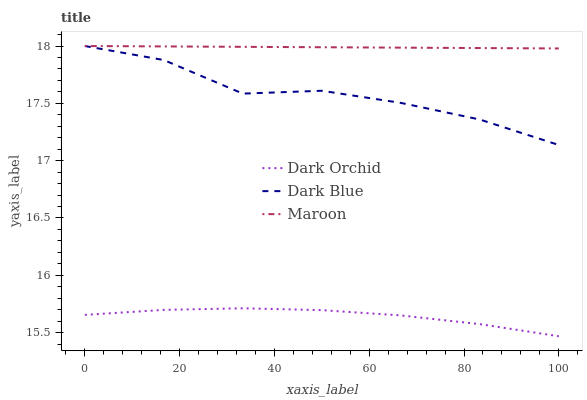Does Dark Orchid have the minimum area under the curve?
Answer yes or no. Yes. Does Maroon have the maximum area under the curve?
Answer yes or no. Yes. Does Maroon have the minimum area under the curve?
Answer yes or no. No. Does Dark Orchid have the maximum area under the curve?
Answer yes or no. No. Is Maroon the smoothest?
Answer yes or no. Yes. Is Dark Blue the roughest?
Answer yes or no. Yes. Is Dark Orchid the smoothest?
Answer yes or no. No. Is Dark Orchid the roughest?
Answer yes or no. No. Does Maroon have the lowest value?
Answer yes or no. No. Does Maroon have the highest value?
Answer yes or no. Yes. Does Dark Orchid have the highest value?
Answer yes or no. No. Is Dark Orchid less than Dark Blue?
Answer yes or no. Yes. Is Maroon greater than Dark Orchid?
Answer yes or no. Yes. Does Dark Blue intersect Maroon?
Answer yes or no. Yes. Is Dark Blue less than Maroon?
Answer yes or no. No. Is Dark Blue greater than Maroon?
Answer yes or no. No. Does Dark Orchid intersect Dark Blue?
Answer yes or no. No. 